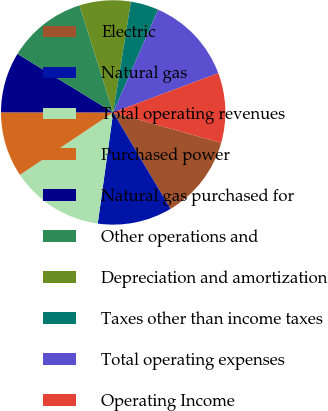<chart> <loc_0><loc_0><loc_500><loc_500><pie_chart><fcel>Electric<fcel>Natural gas<fcel>Total operating revenues<fcel>Purchased power<fcel>Natural gas purchased for<fcel>Other operations and<fcel>Depreciation and amortization<fcel>Taxes other than income taxes<fcel>Total operating expenses<fcel>Operating Income<nl><fcel>12.08%<fcel>10.74%<fcel>13.42%<fcel>9.4%<fcel>8.73%<fcel>11.41%<fcel>7.38%<fcel>4.03%<fcel>12.75%<fcel>10.07%<nl></chart> 